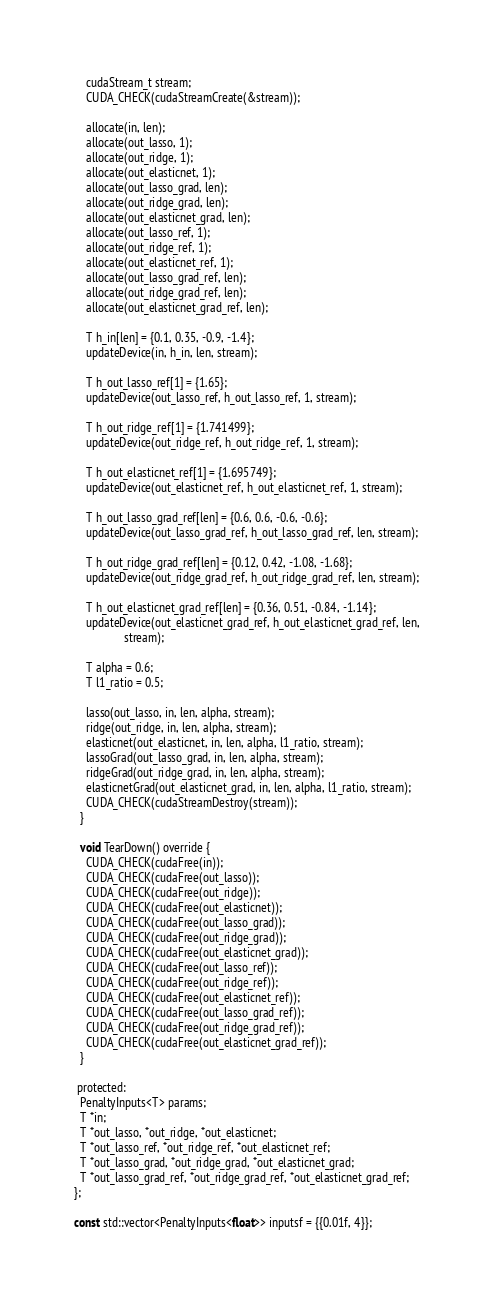Convert code to text. <code><loc_0><loc_0><loc_500><loc_500><_Cuda_>
    cudaStream_t stream;
    CUDA_CHECK(cudaStreamCreate(&stream));

    allocate(in, len);
    allocate(out_lasso, 1);
    allocate(out_ridge, 1);
    allocate(out_elasticnet, 1);
    allocate(out_lasso_grad, len);
    allocate(out_ridge_grad, len);
    allocate(out_elasticnet_grad, len);
    allocate(out_lasso_ref, 1);
    allocate(out_ridge_ref, 1);
    allocate(out_elasticnet_ref, 1);
    allocate(out_lasso_grad_ref, len);
    allocate(out_ridge_grad_ref, len);
    allocate(out_elasticnet_grad_ref, len);

    T h_in[len] = {0.1, 0.35, -0.9, -1.4};
    updateDevice(in, h_in, len, stream);

    T h_out_lasso_ref[1] = {1.65};
    updateDevice(out_lasso_ref, h_out_lasso_ref, 1, stream);

    T h_out_ridge_ref[1] = {1.741499};
    updateDevice(out_ridge_ref, h_out_ridge_ref, 1, stream);

    T h_out_elasticnet_ref[1] = {1.695749};
    updateDevice(out_elasticnet_ref, h_out_elasticnet_ref, 1, stream);

    T h_out_lasso_grad_ref[len] = {0.6, 0.6, -0.6, -0.6};
    updateDevice(out_lasso_grad_ref, h_out_lasso_grad_ref, len, stream);

    T h_out_ridge_grad_ref[len] = {0.12, 0.42, -1.08, -1.68};
    updateDevice(out_ridge_grad_ref, h_out_ridge_grad_ref, len, stream);

    T h_out_elasticnet_grad_ref[len] = {0.36, 0.51, -0.84, -1.14};
    updateDevice(out_elasticnet_grad_ref, h_out_elasticnet_grad_ref, len,
                 stream);

    T alpha = 0.6;
    T l1_ratio = 0.5;

    lasso(out_lasso, in, len, alpha, stream);
    ridge(out_ridge, in, len, alpha, stream);
    elasticnet(out_elasticnet, in, len, alpha, l1_ratio, stream);
    lassoGrad(out_lasso_grad, in, len, alpha, stream);
    ridgeGrad(out_ridge_grad, in, len, alpha, stream);
    elasticnetGrad(out_elasticnet_grad, in, len, alpha, l1_ratio, stream);
    CUDA_CHECK(cudaStreamDestroy(stream));
  }

  void TearDown() override {
    CUDA_CHECK(cudaFree(in));
    CUDA_CHECK(cudaFree(out_lasso));
    CUDA_CHECK(cudaFree(out_ridge));
    CUDA_CHECK(cudaFree(out_elasticnet));
    CUDA_CHECK(cudaFree(out_lasso_grad));
    CUDA_CHECK(cudaFree(out_ridge_grad));
    CUDA_CHECK(cudaFree(out_elasticnet_grad));
    CUDA_CHECK(cudaFree(out_lasso_ref));
    CUDA_CHECK(cudaFree(out_ridge_ref));
    CUDA_CHECK(cudaFree(out_elasticnet_ref));
    CUDA_CHECK(cudaFree(out_lasso_grad_ref));
    CUDA_CHECK(cudaFree(out_ridge_grad_ref));
    CUDA_CHECK(cudaFree(out_elasticnet_grad_ref));
  }

 protected:
  PenaltyInputs<T> params;
  T *in;
  T *out_lasso, *out_ridge, *out_elasticnet;
  T *out_lasso_ref, *out_ridge_ref, *out_elasticnet_ref;
  T *out_lasso_grad, *out_ridge_grad, *out_elasticnet_grad;
  T *out_lasso_grad_ref, *out_ridge_grad_ref, *out_elasticnet_grad_ref;
};

const std::vector<PenaltyInputs<float>> inputsf = {{0.01f, 4}};
</code> 